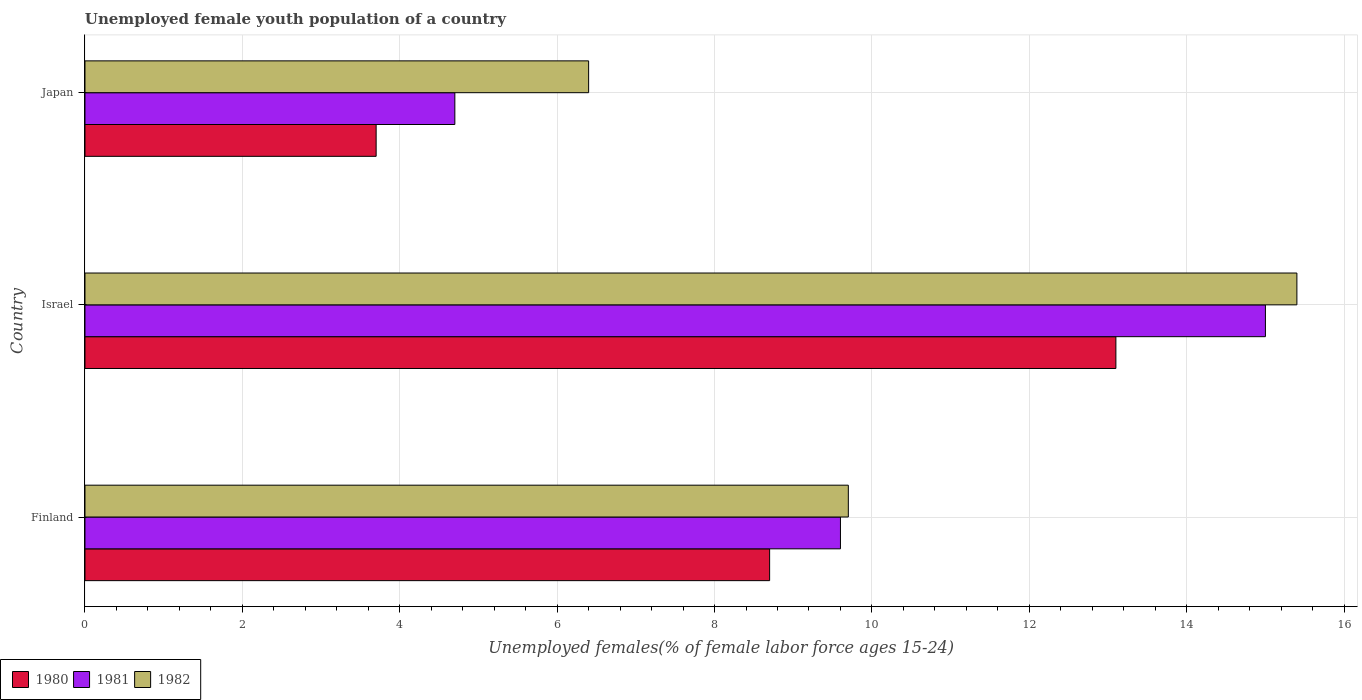How many groups of bars are there?
Keep it short and to the point. 3. What is the percentage of unemployed female youth population in 1981 in Japan?
Your response must be concise. 4.7. Across all countries, what is the maximum percentage of unemployed female youth population in 1980?
Your answer should be compact. 13.1. Across all countries, what is the minimum percentage of unemployed female youth population in 1980?
Make the answer very short. 3.7. What is the total percentage of unemployed female youth population in 1981 in the graph?
Provide a short and direct response. 29.3. What is the difference between the percentage of unemployed female youth population in 1982 in Finland and that in Israel?
Offer a terse response. -5.7. What is the difference between the percentage of unemployed female youth population in 1982 in Israel and the percentage of unemployed female youth population in 1981 in Finland?
Provide a succinct answer. 5.8. What is the average percentage of unemployed female youth population in 1982 per country?
Offer a very short reply. 10.5. What is the difference between the percentage of unemployed female youth population in 1980 and percentage of unemployed female youth population in 1981 in Japan?
Ensure brevity in your answer.  -1. In how many countries, is the percentage of unemployed female youth population in 1980 greater than 12 %?
Provide a short and direct response. 1. What is the ratio of the percentage of unemployed female youth population in 1980 in Finland to that in Israel?
Your answer should be very brief. 0.66. What is the difference between the highest and the second highest percentage of unemployed female youth population in 1982?
Offer a terse response. 5.7. What is the difference between the highest and the lowest percentage of unemployed female youth population in 1980?
Make the answer very short. 9.4. Is the sum of the percentage of unemployed female youth population in 1982 in Finland and Japan greater than the maximum percentage of unemployed female youth population in 1981 across all countries?
Keep it short and to the point. Yes. What does the 2nd bar from the bottom in Finland represents?
Make the answer very short. 1981. Is it the case that in every country, the sum of the percentage of unemployed female youth population in 1982 and percentage of unemployed female youth population in 1981 is greater than the percentage of unemployed female youth population in 1980?
Provide a short and direct response. Yes. How many bars are there?
Your answer should be very brief. 9. Are all the bars in the graph horizontal?
Your answer should be compact. Yes. What is the difference between two consecutive major ticks on the X-axis?
Keep it short and to the point. 2. Does the graph contain any zero values?
Your answer should be very brief. No. Does the graph contain grids?
Offer a terse response. Yes. Where does the legend appear in the graph?
Offer a terse response. Bottom left. How are the legend labels stacked?
Your answer should be very brief. Horizontal. What is the title of the graph?
Give a very brief answer. Unemployed female youth population of a country. What is the label or title of the X-axis?
Keep it short and to the point. Unemployed females(% of female labor force ages 15-24). What is the Unemployed females(% of female labor force ages 15-24) in 1980 in Finland?
Provide a succinct answer. 8.7. What is the Unemployed females(% of female labor force ages 15-24) in 1981 in Finland?
Your answer should be compact. 9.6. What is the Unemployed females(% of female labor force ages 15-24) of 1982 in Finland?
Your answer should be compact. 9.7. What is the Unemployed females(% of female labor force ages 15-24) in 1980 in Israel?
Make the answer very short. 13.1. What is the Unemployed females(% of female labor force ages 15-24) in 1981 in Israel?
Your answer should be very brief. 15. What is the Unemployed females(% of female labor force ages 15-24) in 1982 in Israel?
Your answer should be very brief. 15.4. What is the Unemployed females(% of female labor force ages 15-24) of 1980 in Japan?
Keep it short and to the point. 3.7. What is the Unemployed females(% of female labor force ages 15-24) of 1981 in Japan?
Give a very brief answer. 4.7. What is the Unemployed females(% of female labor force ages 15-24) in 1982 in Japan?
Provide a succinct answer. 6.4. Across all countries, what is the maximum Unemployed females(% of female labor force ages 15-24) in 1980?
Keep it short and to the point. 13.1. Across all countries, what is the maximum Unemployed females(% of female labor force ages 15-24) of 1982?
Ensure brevity in your answer.  15.4. Across all countries, what is the minimum Unemployed females(% of female labor force ages 15-24) in 1980?
Your response must be concise. 3.7. Across all countries, what is the minimum Unemployed females(% of female labor force ages 15-24) of 1981?
Give a very brief answer. 4.7. Across all countries, what is the minimum Unemployed females(% of female labor force ages 15-24) in 1982?
Give a very brief answer. 6.4. What is the total Unemployed females(% of female labor force ages 15-24) in 1980 in the graph?
Make the answer very short. 25.5. What is the total Unemployed females(% of female labor force ages 15-24) in 1981 in the graph?
Offer a terse response. 29.3. What is the total Unemployed females(% of female labor force ages 15-24) of 1982 in the graph?
Give a very brief answer. 31.5. What is the difference between the Unemployed females(% of female labor force ages 15-24) of 1980 in Finland and that in Israel?
Ensure brevity in your answer.  -4.4. What is the difference between the Unemployed females(% of female labor force ages 15-24) in 1982 in Finland and that in Japan?
Offer a terse response. 3.3. What is the difference between the Unemployed females(% of female labor force ages 15-24) of 1980 in Israel and that in Japan?
Provide a short and direct response. 9.4. What is the difference between the Unemployed females(% of female labor force ages 15-24) of 1981 in Israel and that in Japan?
Provide a succinct answer. 10.3. What is the difference between the Unemployed females(% of female labor force ages 15-24) of 1982 in Israel and that in Japan?
Provide a succinct answer. 9. What is the difference between the Unemployed females(% of female labor force ages 15-24) in 1981 in Finland and the Unemployed females(% of female labor force ages 15-24) in 1982 in Israel?
Your response must be concise. -5.8. What is the difference between the Unemployed females(% of female labor force ages 15-24) in 1981 in Finland and the Unemployed females(% of female labor force ages 15-24) in 1982 in Japan?
Give a very brief answer. 3.2. What is the difference between the Unemployed females(% of female labor force ages 15-24) in 1980 in Israel and the Unemployed females(% of female labor force ages 15-24) in 1982 in Japan?
Your answer should be compact. 6.7. What is the average Unemployed females(% of female labor force ages 15-24) of 1980 per country?
Offer a very short reply. 8.5. What is the average Unemployed females(% of female labor force ages 15-24) of 1981 per country?
Keep it short and to the point. 9.77. What is the average Unemployed females(% of female labor force ages 15-24) in 1982 per country?
Keep it short and to the point. 10.5. What is the difference between the Unemployed females(% of female labor force ages 15-24) of 1981 and Unemployed females(% of female labor force ages 15-24) of 1982 in Israel?
Give a very brief answer. -0.4. What is the difference between the Unemployed females(% of female labor force ages 15-24) of 1980 and Unemployed females(% of female labor force ages 15-24) of 1981 in Japan?
Ensure brevity in your answer.  -1. What is the difference between the Unemployed females(% of female labor force ages 15-24) in 1980 and Unemployed females(% of female labor force ages 15-24) in 1982 in Japan?
Keep it short and to the point. -2.7. What is the ratio of the Unemployed females(% of female labor force ages 15-24) of 1980 in Finland to that in Israel?
Provide a succinct answer. 0.66. What is the ratio of the Unemployed females(% of female labor force ages 15-24) of 1981 in Finland to that in Israel?
Provide a short and direct response. 0.64. What is the ratio of the Unemployed females(% of female labor force ages 15-24) of 1982 in Finland to that in Israel?
Make the answer very short. 0.63. What is the ratio of the Unemployed females(% of female labor force ages 15-24) of 1980 in Finland to that in Japan?
Provide a succinct answer. 2.35. What is the ratio of the Unemployed females(% of female labor force ages 15-24) of 1981 in Finland to that in Japan?
Your response must be concise. 2.04. What is the ratio of the Unemployed females(% of female labor force ages 15-24) in 1982 in Finland to that in Japan?
Your answer should be compact. 1.52. What is the ratio of the Unemployed females(% of female labor force ages 15-24) of 1980 in Israel to that in Japan?
Your answer should be very brief. 3.54. What is the ratio of the Unemployed females(% of female labor force ages 15-24) of 1981 in Israel to that in Japan?
Provide a short and direct response. 3.19. What is the ratio of the Unemployed females(% of female labor force ages 15-24) in 1982 in Israel to that in Japan?
Keep it short and to the point. 2.41. What is the difference between the highest and the second highest Unemployed females(% of female labor force ages 15-24) of 1980?
Make the answer very short. 4.4. What is the difference between the highest and the second highest Unemployed females(% of female labor force ages 15-24) in 1982?
Give a very brief answer. 5.7. What is the difference between the highest and the lowest Unemployed females(% of female labor force ages 15-24) of 1981?
Provide a succinct answer. 10.3. What is the difference between the highest and the lowest Unemployed females(% of female labor force ages 15-24) in 1982?
Your response must be concise. 9. 